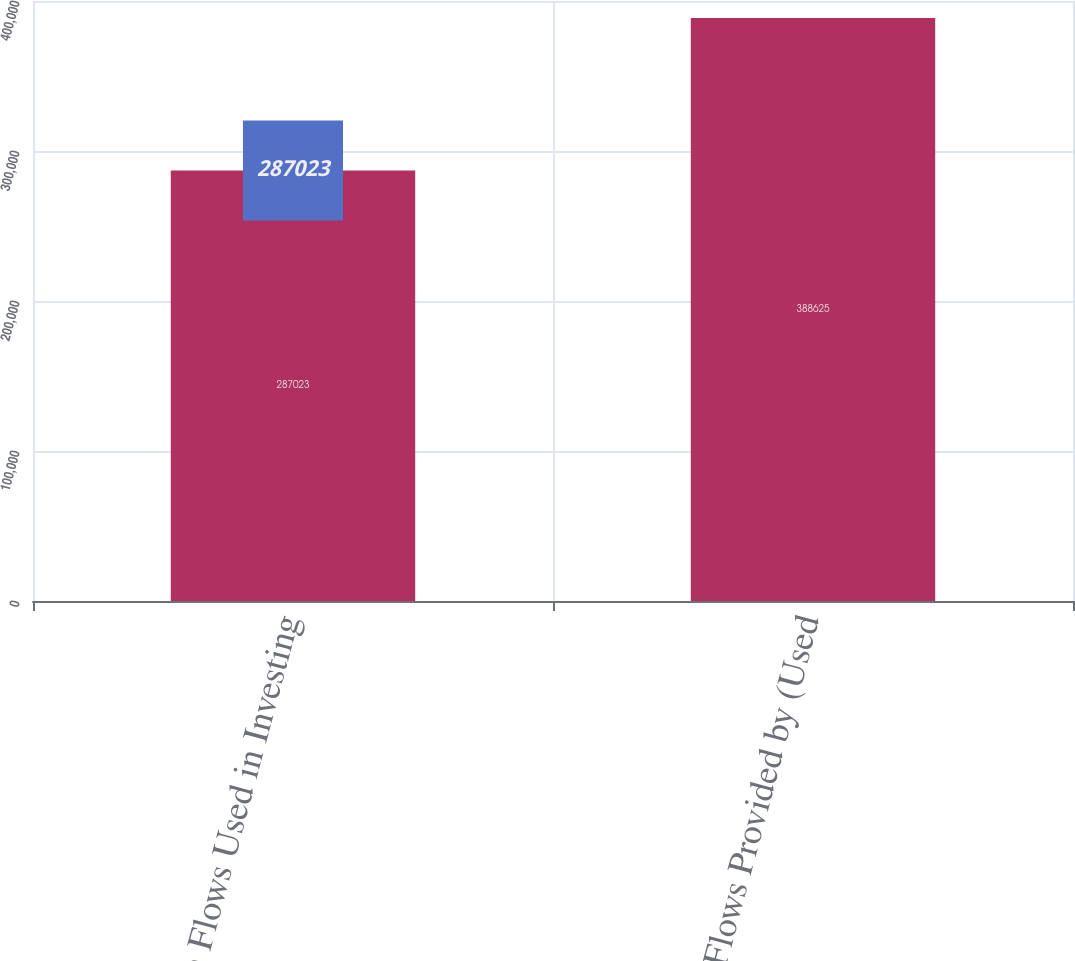Convert chart to OTSL. <chart><loc_0><loc_0><loc_500><loc_500><bar_chart><fcel>Cash Flows Used in Investing<fcel>Cash Flows Provided by (Used<nl><fcel>287023<fcel>388625<nl></chart> 